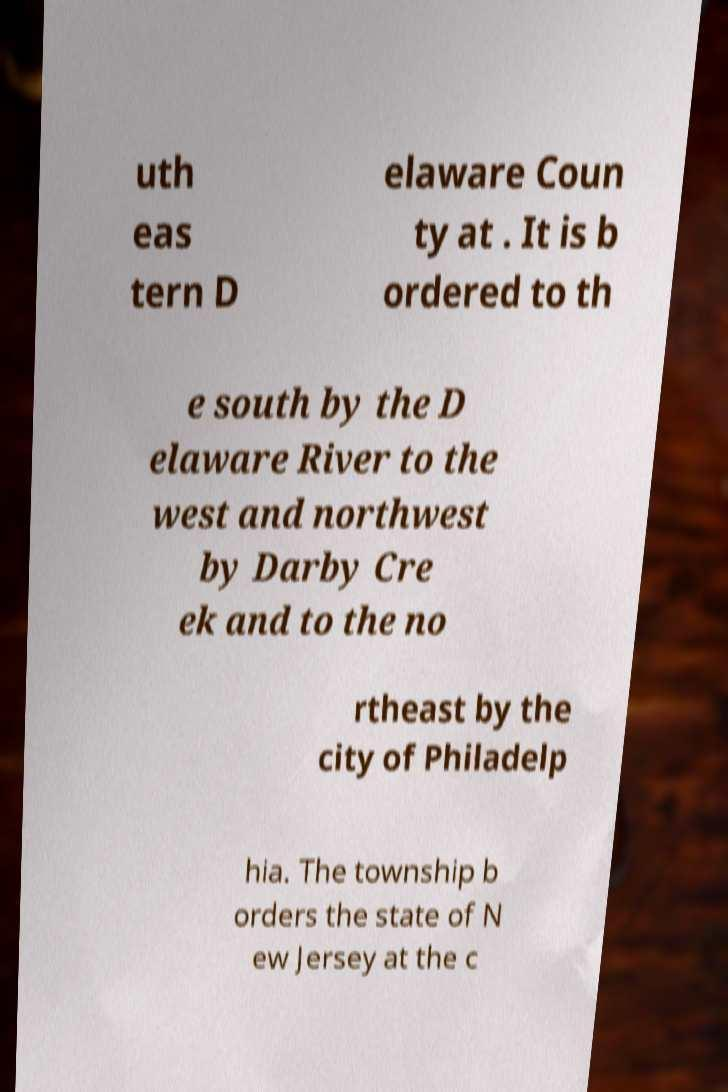Could you extract and type out the text from this image? uth eas tern D elaware Coun ty at . It is b ordered to th e south by the D elaware River to the west and northwest by Darby Cre ek and to the no rtheast by the city of Philadelp hia. The township b orders the state of N ew Jersey at the c 